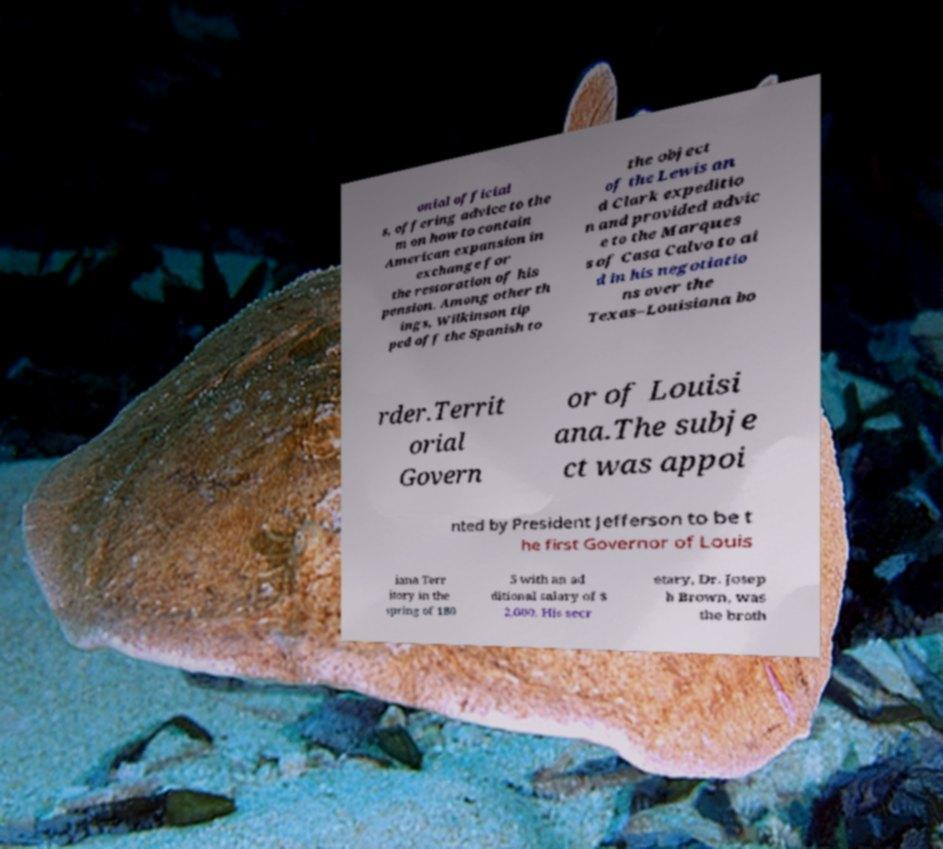Can you accurately transcribe the text from the provided image for me? onial official s, offering advice to the m on how to contain American expansion in exchange for the restoration of his pension. Among other th ings, Wilkinson tip ped off the Spanish to the object of the Lewis an d Clark expeditio n and provided advic e to the Marques s of Casa Calvo to ai d in his negotiatio ns over the Texas–Louisiana bo rder.Territ orial Govern or of Louisi ana.The subje ct was appoi nted by President Jefferson to be t he first Governor of Louis iana Terr itory in the spring of 180 5 with an ad ditional salary of $ 2,000. His secr etary, Dr. Josep h Brown, was the broth 